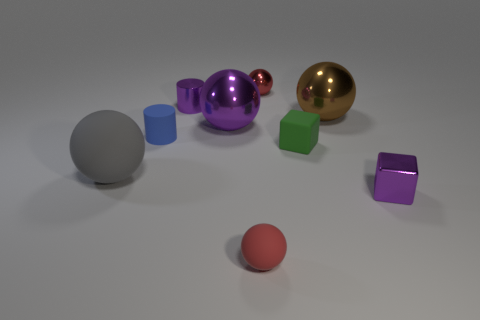Are there any matte things?
Make the answer very short. Yes. There is a rubber object that is both right of the small blue cylinder and behind the tiny shiny cube; how big is it?
Your response must be concise. Small. There is a blue thing; what shape is it?
Provide a succinct answer. Cylinder. There is a purple object right of the red rubber sphere; is there a small matte cylinder right of it?
Provide a succinct answer. No. There is a blue cylinder that is the same size as the purple block; what is it made of?
Give a very brief answer. Rubber. Are there any rubber balls of the same size as the red metallic ball?
Ensure brevity in your answer.  Yes. What is the material of the tiny object on the left side of the small purple cylinder?
Provide a short and direct response. Rubber. Do the cube in front of the large gray object and the blue cylinder have the same material?
Ensure brevity in your answer.  No. There is a red shiny object that is the same size as the shiny cube; what shape is it?
Your answer should be compact. Sphere. What number of big rubber spheres have the same color as the matte cube?
Make the answer very short. 0. 